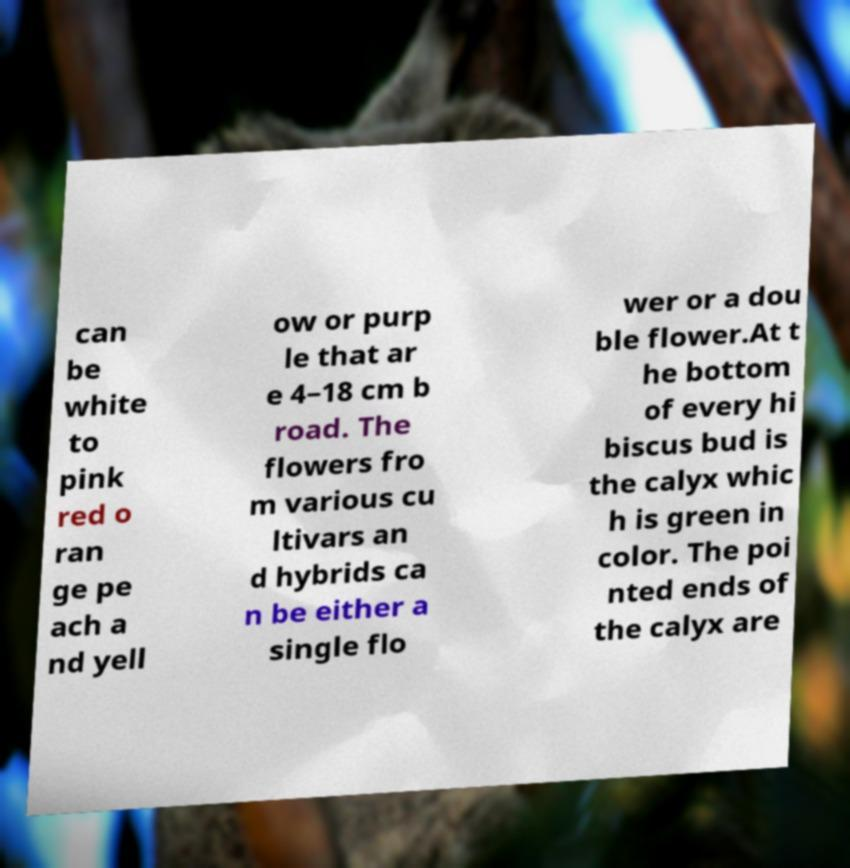Could you assist in decoding the text presented in this image and type it out clearly? can be white to pink red o ran ge pe ach a nd yell ow or purp le that ar e 4–18 cm b road. The flowers fro m various cu ltivars an d hybrids ca n be either a single flo wer or a dou ble flower.At t he bottom of every hi biscus bud is the calyx whic h is green in color. The poi nted ends of the calyx are 